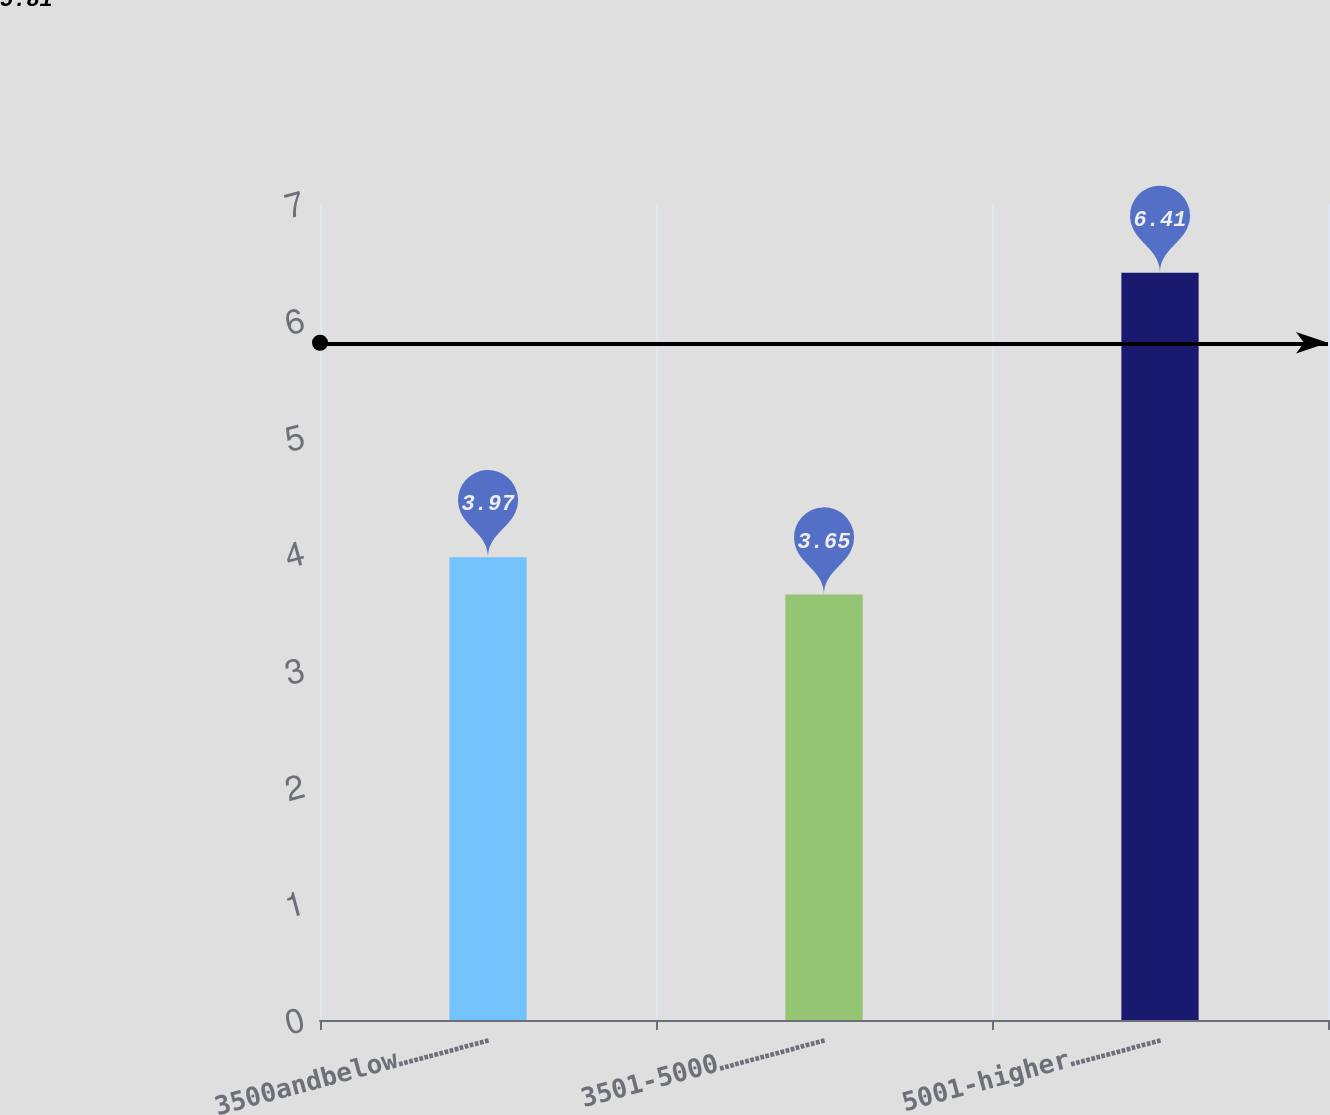<chart> <loc_0><loc_0><loc_500><loc_500><bar_chart><fcel>3500andbelow………………<fcel>3501-5000…………………<fcel>5001-higher………………<nl><fcel>3.97<fcel>3.65<fcel>6.41<nl></chart> 